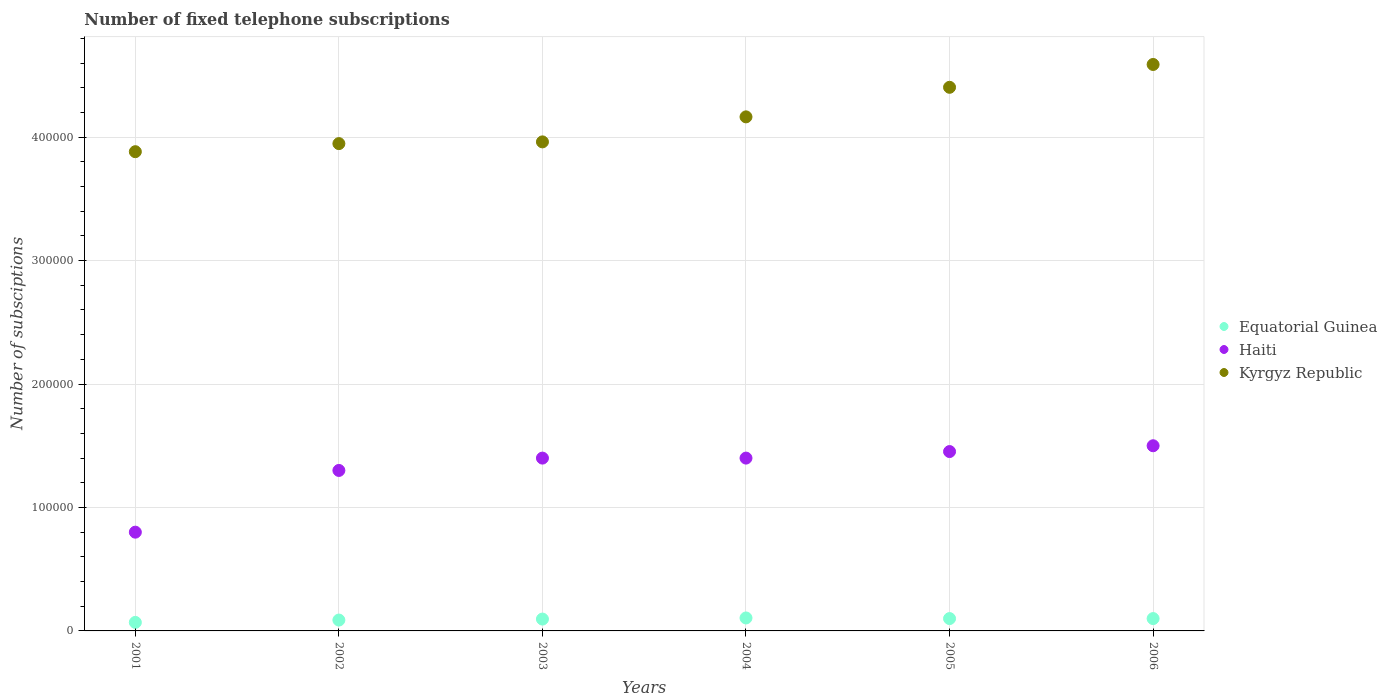What is the number of fixed telephone subscriptions in Kyrgyz Republic in 2003?
Offer a terse response. 3.96e+05. Across all years, what is the maximum number of fixed telephone subscriptions in Haiti?
Give a very brief answer. 1.50e+05. Across all years, what is the minimum number of fixed telephone subscriptions in Equatorial Guinea?
Your answer should be very brief. 6900. In which year was the number of fixed telephone subscriptions in Equatorial Guinea maximum?
Offer a very short reply. 2004. In which year was the number of fixed telephone subscriptions in Equatorial Guinea minimum?
Your answer should be compact. 2001. What is the total number of fixed telephone subscriptions in Haiti in the graph?
Your answer should be very brief. 7.85e+05. What is the difference between the number of fixed telephone subscriptions in Equatorial Guinea in 2006 and the number of fixed telephone subscriptions in Haiti in 2001?
Your response must be concise. -7.00e+04. What is the average number of fixed telephone subscriptions in Haiti per year?
Keep it short and to the point. 1.31e+05. In the year 2002, what is the difference between the number of fixed telephone subscriptions in Equatorial Guinea and number of fixed telephone subscriptions in Haiti?
Keep it short and to the point. -1.21e+05. What is the ratio of the number of fixed telephone subscriptions in Haiti in 2002 to that in 2003?
Give a very brief answer. 0.93. Is the number of fixed telephone subscriptions in Haiti in 2003 less than that in 2005?
Offer a terse response. Yes. Is the difference between the number of fixed telephone subscriptions in Equatorial Guinea in 2004 and 2005 greater than the difference between the number of fixed telephone subscriptions in Haiti in 2004 and 2005?
Provide a succinct answer. Yes. In how many years, is the number of fixed telephone subscriptions in Haiti greater than the average number of fixed telephone subscriptions in Haiti taken over all years?
Keep it short and to the point. 4. Is it the case that in every year, the sum of the number of fixed telephone subscriptions in Equatorial Guinea and number of fixed telephone subscriptions in Kyrgyz Republic  is greater than the number of fixed telephone subscriptions in Haiti?
Your response must be concise. Yes. Does the number of fixed telephone subscriptions in Equatorial Guinea monotonically increase over the years?
Your response must be concise. No. Is the number of fixed telephone subscriptions in Equatorial Guinea strictly greater than the number of fixed telephone subscriptions in Haiti over the years?
Your answer should be compact. No. Is the number of fixed telephone subscriptions in Kyrgyz Republic strictly less than the number of fixed telephone subscriptions in Equatorial Guinea over the years?
Give a very brief answer. No. What is the difference between two consecutive major ticks on the Y-axis?
Your answer should be very brief. 1.00e+05. Are the values on the major ticks of Y-axis written in scientific E-notation?
Your answer should be very brief. No. Does the graph contain any zero values?
Your response must be concise. No. Where does the legend appear in the graph?
Keep it short and to the point. Center right. How many legend labels are there?
Your response must be concise. 3. How are the legend labels stacked?
Provide a short and direct response. Vertical. What is the title of the graph?
Your response must be concise. Number of fixed telephone subscriptions. What is the label or title of the Y-axis?
Offer a very short reply. Number of subsciptions. What is the Number of subsciptions of Equatorial Guinea in 2001?
Keep it short and to the point. 6900. What is the Number of subsciptions of Haiti in 2001?
Offer a terse response. 8.00e+04. What is the Number of subsciptions of Kyrgyz Republic in 2001?
Offer a terse response. 3.88e+05. What is the Number of subsciptions of Equatorial Guinea in 2002?
Your response must be concise. 8800. What is the Number of subsciptions of Haiti in 2002?
Your answer should be very brief. 1.30e+05. What is the Number of subsciptions of Kyrgyz Republic in 2002?
Your answer should be compact. 3.95e+05. What is the Number of subsciptions in Equatorial Guinea in 2003?
Make the answer very short. 9600. What is the Number of subsciptions in Haiti in 2003?
Keep it short and to the point. 1.40e+05. What is the Number of subsciptions of Kyrgyz Republic in 2003?
Your answer should be compact. 3.96e+05. What is the Number of subsciptions of Equatorial Guinea in 2004?
Provide a succinct answer. 1.05e+04. What is the Number of subsciptions of Haiti in 2004?
Offer a very short reply. 1.40e+05. What is the Number of subsciptions of Kyrgyz Republic in 2004?
Provide a succinct answer. 4.16e+05. What is the Number of subsciptions in Haiti in 2005?
Provide a short and direct response. 1.45e+05. What is the Number of subsciptions of Kyrgyz Republic in 2005?
Offer a very short reply. 4.40e+05. What is the Number of subsciptions in Haiti in 2006?
Your response must be concise. 1.50e+05. What is the Number of subsciptions of Kyrgyz Republic in 2006?
Ensure brevity in your answer.  4.59e+05. Across all years, what is the maximum Number of subsciptions of Equatorial Guinea?
Your answer should be very brief. 1.05e+04. Across all years, what is the maximum Number of subsciptions of Kyrgyz Republic?
Ensure brevity in your answer.  4.59e+05. Across all years, what is the minimum Number of subsciptions in Equatorial Guinea?
Give a very brief answer. 6900. Across all years, what is the minimum Number of subsciptions of Haiti?
Provide a short and direct response. 8.00e+04. Across all years, what is the minimum Number of subsciptions in Kyrgyz Republic?
Your response must be concise. 3.88e+05. What is the total Number of subsciptions of Equatorial Guinea in the graph?
Your answer should be compact. 5.58e+04. What is the total Number of subsciptions of Haiti in the graph?
Offer a terse response. 7.85e+05. What is the total Number of subsciptions of Kyrgyz Republic in the graph?
Ensure brevity in your answer.  2.49e+06. What is the difference between the Number of subsciptions of Equatorial Guinea in 2001 and that in 2002?
Ensure brevity in your answer.  -1900. What is the difference between the Number of subsciptions of Haiti in 2001 and that in 2002?
Your answer should be compact. -5.00e+04. What is the difference between the Number of subsciptions of Kyrgyz Republic in 2001 and that in 2002?
Keep it short and to the point. -6548. What is the difference between the Number of subsciptions in Equatorial Guinea in 2001 and that in 2003?
Provide a short and direct response. -2700. What is the difference between the Number of subsciptions of Kyrgyz Republic in 2001 and that in 2003?
Provide a succinct answer. -7946. What is the difference between the Number of subsciptions of Equatorial Guinea in 2001 and that in 2004?
Ensure brevity in your answer.  -3600. What is the difference between the Number of subsciptions of Haiti in 2001 and that in 2004?
Offer a terse response. -6.00e+04. What is the difference between the Number of subsciptions in Kyrgyz Republic in 2001 and that in 2004?
Your answer should be compact. -2.82e+04. What is the difference between the Number of subsciptions in Equatorial Guinea in 2001 and that in 2005?
Give a very brief answer. -3100. What is the difference between the Number of subsciptions of Haiti in 2001 and that in 2005?
Keep it short and to the point. -6.53e+04. What is the difference between the Number of subsciptions of Kyrgyz Republic in 2001 and that in 2005?
Keep it short and to the point. -5.22e+04. What is the difference between the Number of subsciptions in Equatorial Guinea in 2001 and that in 2006?
Your response must be concise. -3100. What is the difference between the Number of subsciptions in Haiti in 2001 and that in 2006?
Give a very brief answer. -7.00e+04. What is the difference between the Number of subsciptions in Kyrgyz Republic in 2001 and that in 2006?
Offer a very short reply. -7.07e+04. What is the difference between the Number of subsciptions in Equatorial Guinea in 2002 and that in 2003?
Your answer should be compact. -800. What is the difference between the Number of subsciptions in Haiti in 2002 and that in 2003?
Provide a succinct answer. -10000. What is the difference between the Number of subsciptions in Kyrgyz Republic in 2002 and that in 2003?
Offer a terse response. -1398. What is the difference between the Number of subsciptions in Equatorial Guinea in 2002 and that in 2004?
Provide a short and direct response. -1700. What is the difference between the Number of subsciptions in Kyrgyz Republic in 2002 and that in 2004?
Provide a succinct answer. -2.17e+04. What is the difference between the Number of subsciptions in Equatorial Guinea in 2002 and that in 2005?
Ensure brevity in your answer.  -1200. What is the difference between the Number of subsciptions in Haiti in 2002 and that in 2005?
Give a very brief answer. -1.53e+04. What is the difference between the Number of subsciptions of Kyrgyz Republic in 2002 and that in 2005?
Keep it short and to the point. -4.56e+04. What is the difference between the Number of subsciptions of Equatorial Guinea in 2002 and that in 2006?
Provide a short and direct response. -1200. What is the difference between the Number of subsciptions in Haiti in 2002 and that in 2006?
Provide a succinct answer. -2.00e+04. What is the difference between the Number of subsciptions of Kyrgyz Republic in 2002 and that in 2006?
Your answer should be compact. -6.41e+04. What is the difference between the Number of subsciptions of Equatorial Guinea in 2003 and that in 2004?
Offer a terse response. -900. What is the difference between the Number of subsciptions in Haiti in 2003 and that in 2004?
Your answer should be compact. 0. What is the difference between the Number of subsciptions of Kyrgyz Republic in 2003 and that in 2004?
Offer a terse response. -2.03e+04. What is the difference between the Number of subsciptions of Equatorial Guinea in 2003 and that in 2005?
Offer a very short reply. -400. What is the difference between the Number of subsciptions of Haiti in 2003 and that in 2005?
Offer a very short reply. -5300. What is the difference between the Number of subsciptions of Kyrgyz Republic in 2003 and that in 2005?
Keep it short and to the point. -4.42e+04. What is the difference between the Number of subsciptions of Equatorial Guinea in 2003 and that in 2006?
Offer a terse response. -400. What is the difference between the Number of subsciptions in Haiti in 2003 and that in 2006?
Your response must be concise. -10000. What is the difference between the Number of subsciptions of Kyrgyz Republic in 2003 and that in 2006?
Make the answer very short. -6.27e+04. What is the difference between the Number of subsciptions of Equatorial Guinea in 2004 and that in 2005?
Provide a succinct answer. 500. What is the difference between the Number of subsciptions of Haiti in 2004 and that in 2005?
Your answer should be very brief. -5300. What is the difference between the Number of subsciptions in Kyrgyz Republic in 2004 and that in 2005?
Your answer should be compact. -2.40e+04. What is the difference between the Number of subsciptions of Equatorial Guinea in 2004 and that in 2006?
Provide a succinct answer. 500. What is the difference between the Number of subsciptions in Haiti in 2004 and that in 2006?
Provide a succinct answer. -10000. What is the difference between the Number of subsciptions of Kyrgyz Republic in 2004 and that in 2006?
Ensure brevity in your answer.  -4.24e+04. What is the difference between the Number of subsciptions in Haiti in 2005 and that in 2006?
Ensure brevity in your answer.  -4700. What is the difference between the Number of subsciptions in Kyrgyz Republic in 2005 and that in 2006?
Offer a terse response. -1.85e+04. What is the difference between the Number of subsciptions in Equatorial Guinea in 2001 and the Number of subsciptions in Haiti in 2002?
Provide a short and direct response. -1.23e+05. What is the difference between the Number of subsciptions in Equatorial Guinea in 2001 and the Number of subsciptions in Kyrgyz Republic in 2002?
Your response must be concise. -3.88e+05. What is the difference between the Number of subsciptions of Haiti in 2001 and the Number of subsciptions of Kyrgyz Republic in 2002?
Your answer should be very brief. -3.15e+05. What is the difference between the Number of subsciptions in Equatorial Guinea in 2001 and the Number of subsciptions in Haiti in 2003?
Your answer should be very brief. -1.33e+05. What is the difference between the Number of subsciptions in Equatorial Guinea in 2001 and the Number of subsciptions in Kyrgyz Republic in 2003?
Make the answer very short. -3.89e+05. What is the difference between the Number of subsciptions in Haiti in 2001 and the Number of subsciptions in Kyrgyz Republic in 2003?
Provide a short and direct response. -3.16e+05. What is the difference between the Number of subsciptions of Equatorial Guinea in 2001 and the Number of subsciptions of Haiti in 2004?
Ensure brevity in your answer.  -1.33e+05. What is the difference between the Number of subsciptions of Equatorial Guinea in 2001 and the Number of subsciptions of Kyrgyz Republic in 2004?
Make the answer very short. -4.10e+05. What is the difference between the Number of subsciptions of Haiti in 2001 and the Number of subsciptions of Kyrgyz Republic in 2004?
Provide a succinct answer. -3.36e+05. What is the difference between the Number of subsciptions of Equatorial Guinea in 2001 and the Number of subsciptions of Haiti in 2005?
Offer a terse response. -1.38e+05. What is the difference between the Number of subsciptions of Equatorial Guinea in 2001 and the Number of subsciptions of Kyrgyz Republic in 2005?
Offer a terse response. -4.33e+05. What is the difference between the Number of subsciptions in Haiti in 2001 and the Number of subsciptions in Kyrgyz Republic in 2005?
Your answer should be compact. -3.60e+05. What is the difference between the Number of subsciptions of Equatorial Guinea in 2001 and the Number of subsciptions of Haiti in 2006?
Keep it short and to the point. -1.43e+05. What is the difference between the Number of subsciptions of Equatorial Guinea in 2001 and the Number of subsciptions of Kyrgyz Republic in 2006?
Make the answer very short. -4.52e+05. What is the difference between the Number of subsciptions of Haiti in 2001 and the Number of subsciptions of Kyrgyz Republic in 2006?
Your answer should be compact. -3.79e+05. What is the difference between the Number of subsciptions of Equatorial Guinea in 2002 and the Number of subsciptions of Haiti in 2003?
Keep it short and to the point. -1.31e+05. What is the difference between the Number of subsciptions of Equatorial Guinea in 2002 and the Number of subsciptions of Kyrgyz Republic in 2003?
Offer a terse response. -3.87e+05. What is the difference between the Number of subsciptions of Haiti in 2002 and the Number of subsciptions of Kyrgyz Republic in 2003?
Your response must be concise. -2.66e+05. What is the difference between the Number of subsciptions of Equatorial Guinea in 2002 and the Number of subsciptions of Haiti in 2004?
Give a very brief answer. -1.31e+05. What is the difference between the Number of subsciptions of Equatorial Guinea in 2002 and the Number of subsciptions of Kyrgyz Republic in 2004?
Provide a short and direct response. -4.08e+05. What is the difference between the Number of subsciptions of Haiti in 2002 and the Number of subsciptions of Kyrgyz Republic in 2004?
Offer a terse response. -2.86e+05. What is the difference between the Number of subsciptions of Equatorial Guinea in 2002 and the Number of subsciptions of Haiti in 2005?
Provide a succinct answer. -1.36e+05. What is the difference between the Number of subsciptions of Equatorial Guinea in 2002 and the Number of subsciptions of Kyrgyz Republic in 2005?
Keep it short and to the point. -4.32e+05. What is the difference between the Number of subsciptions of Haiti in 2002 and the Number of subsciptions of Kyrgyz Republic in 2005?
Keep it short and to the point. -3.10e+05. What is the difference between the Number of subsciptions of Equatorial Guinea in 2002 and the Number of subsciptions of Haiti in 2006?
Your response must be concise. -1.41e+05. What is the difference between the Number of subsciptions in Equatorial Guinea in 2002 and the Number of subsciptions in Kyrgyz Republic in 2006?
Your answer should be very brief. -4.50e+05. What is the difference between the Number of subsciptions of Haiti in 2002 and the Number of subsciptions of Kyrgyz Republic in 2006?
Your answer should be compact. -3.29e+05. What is the difference between the Number of subsciptions in Equatorial Guinea in 2003 and the Number of subsciptions in Haiti in 2004?
Your response must be concise. -1.30e+05. What is the difference between the Number of subsciptions of Equatorial Guinea in 2003 and the Number of subsciptions of Kyrgyz Republic in 2004?
Offer a very short reply. -4.07e+05. What is the difference between the Number of subsciptions in Haiti in 2003 and the Number of subsciptions in Kyrgyz Republic in 2004?
Your answer should be very brief. -2.76e+05. What is the difference between the Number of subsciptions in Equatorial Guinea in 2003 and the Number of subsciptions in Haiti in 2005?
Your response must be concise. -1.36e+05. What is the difference between the Number of subsciptions in Equatorial Guinea in 2003 and the Number of subsciptions in Kyrgyz Republic in 2005?
Keep it short and to the point. -4.31e+05. What is the difference between the Number of subsciptions in Haiti in 2003 and the Number of subsciptions in Kyrgyz Republic in 2005?
Keep it short and to the point. -3.00e+05. What is the difference between the Number of subsciptions in Equatorial Guinea in 2003 and the Number of subsciptions in Haiti in 2006?
Your answer should be very brief. -1.40e+05. What is the difference between the Number of subsciptions in Equatorial Guinea in 2003 and the Number of subsciptions in Kyrgyz Republic in 2006?
Provide a succinct answer. -4.49e+05. What is the difference between the Number of subsciptions in Haiti in 2003 and the Number of subsciptions in Kyrgyz Republic in 2006?
Offer a very short reply. -3.19e+05. What is the difference between the Number of subsciptions of Equatorial Guinea in 2004 and the Number of subsciptions of Haiti in 2005?
Provide a succinct answer. -1.35e+05. What is the difference between the Number of subsciptions of Equatorial Guinea in 2004 and the Number of subsciptions of Kyrgyz Republic in 2005?
Make the answer very short. -4.30e+05. What is the difference between the Number of subsciptions in Haiti in 2004 and the Number of subsciptions in Kyrgyz Republic in 2005?
Provide a short and direct response. -3.00e+05. What is the difference between the Number of subsciptions in Equatorial Guinea in 2004 and the Number of subsciptions in Haiti in 2006?
Provide a succinct answer. -1.40e+05. What is the difference between the Number of subsciptions of Equatorial Guinea in 2004 and the Number of subsciptions of Kyrgyz Republic in 2006?
Make the answer very short. -4.48e+05. What is the difference between the Number of subsciptions of Haiti in 2004 and the Number of subsciptions of Kyrgyz Republic in 2006?
Ensure brevity in your answer.  -3.19e+05. What is the difference between the Number of subsciptions of Equatorial Guinea in 2005 and the Number of subsciptions of Kyrgyz Republic in 2006?
Offer a very short reply. -4.49e+05. What is the difference between the Number of subsciptions of Haiti in 2005 and the Number of subsciptions of Kyrgyz Republic in 2006?
Your response must be concise. -3.14e+05. What is the average Number of subsciptions of Equatorial Guinea per year?
Keep it short and to the point. 9300. What is the average Number of subsciptions in Haiti per year?
Provide a short and direct response. 1.31e+05. What is the average Number of subsciptions in Kyrgyz Republic per year?
Provide a short and direct response. 4.16e+05. In the year 2001, what is the difference between the Number of subsciptions in Equatorial Guinea and Number of subsciptions in Haiti?
Ensure brevity in your answer.  -7.31e+04. In the year 2001, what is the difference between the Number of subsciptions of Equatorial Guinea and Number of subsciptions of Kyrgyz Republic?
Provide a succinct answer. -3.81e+05. In the year 2001, what is the difference between the Number of subsciptions of Haiti and Number of subsciptions of Kyrgyz Republic?
Provide a short and direct response. -3.08e+05. In the year 2002, what is the difference between the Number of subsciptions of Equatorial Guinea and Number of subsciptions of Haiti?
Give a very brief answer. -1.21e+05. In the year 2002, what is the difference between the Number of subsciptions of Equatorial Guinea and Number of subsciptions of Kyrgyz Republic?
Offer a very short reply. -3.86e+05. In the year 2002, what is the difference between the Number of subsciptions of Haiti and Number of subsciptions of Kyrgyz Republic?
Give a very brief answer. -2.65e+05. In the year 2003, what is the difference between the Number of subsciptions in Equatorial Guinea and Number of subsciptions in Haiti?
Your answer should be compact. -1.30e+05. In the year 2003, what is the difference between the Number of subsciptions in Equatorial Guinea and Number of subsciptions in Kyrgyz Republic?
Offer a very short reply. -3.87e+05. In the year 2003, what is the difference between the Number of subsciptions of Haiti and Number of subsciptions of Kyrgyz Republic?
Offer a very short reply. -2.56e+05. In the year 2004, what is the difference between the Number of subsciptions in Equatorial Guinea and Number of subsciptions in Haiti?
Keep it short and to the point. -1.30e+05. In the year 2004, what is the difference between the Number of subsciptions of Equatorial Guinea and Number of subsciptions of Kyrgyz Republic?
Provide a short and direct response. -4.06e+05. In the year 2004, what is the difference between the Number of subsciptions of Haiti and Number of subsciptions of Kyrgyz Republic?
Your response must be concise. -2.76e+05. In the year 2005, what is the difference between the Number of subsciptions of Equatorial Guinea and Number of subsciptions of Haiti?
Provide a short and direct response. -1.35e+05. In the year 2005, what is the difference between the Number of subsciptions in Equatorial Guinea and Number of subsciptions in Kyrgyz Republic?
Provide a short and direct response. -4.30e+05. In the year 2005, what is the difference between the Number of subsciptions of Haiti and Number of subsciptions of Kyrgyz Republic?
Offer a terse response. -2.95e+05. In the year 2006, what is the difference between the Number of subsciptions of Equatorial Guinea and Number of subsciptions of Haiti?
Offer a very short reply. -1.40e+05. In the year 2006, what is the difference between the Number of subsciptions in Equatorial Guinea and Number of subsciptions in Kyrgyz Republic?
Make the answer very short. -4.49e+05. In the year 2006, what is the difference between the Number of subsciptions of Haiti and Number of subsciptions of Kyrgyz Republic?
Your response must be concise. -3.09e+05. What is the ratio of the Number of subsciptions of Equatorial Guinea in 2001 to that in 2002?
Give a very brief answer. 0.78. What is the ratio of the Number of subsciptions in Haiti in 2001 to that in 2002?
Make the answer very short. 0.62. What is the ratio of the Number of subsciptions in Kyrgyz Republic in 2001 to that in 2002?
Your answer should be compact. 0.98. What is the ratio of the Number of subsciptions in Equatorial Guinea in 2001 to that in 2003?
Keep it short and to the point. 0.72. What is the ratio of the Number of subsciptions in Haiti in 2001 to that in 2003?
Offer a very short reply. 0.57. What is the ratio of the Number of subsciptions of Kyrgyz Republic in 2001 to that in 2003?
Offer a very short reply. 0.98. What is the ratio of the Number of subsciptions of Equatorial Guinea in 2001 to that in 2004?
Your response must be concise. 0.66. What is the ratio of the Number of subsciptions of Haiti in 2001 to that in 2004?
Ensure brevity in your answer.  0.57. What is the ratio of the Number of subsciptions of Kyrgyz Republic in 2001 to that in 2004?
Make the answer very short. 0.93. What is the ratio of the Number of subsciptions of Equatorial Guinea in 2001 to that in 2005?
Offer a very short reply. 0.69. What is the ratio of the Number of subsciptions in Haiti in 2001 to that in 2005?
Provide a short and direct response. 0.55. What is the ratio of the Number of subsciptions of Kyrgyz Republic in 2001 to that in 2005?
Keep it short and to the point. 0.88. What is the ratio of the Number of subsciptions of Equatorial Guinea in 2001 to that in 2006?
Offer a very short reply. 0.69. What is the ratio of the Number of subsciptions in Haiti in 2001 to that in 2006?
Give a very brief answer. 0.53. What is the ratio of the Number of subsciptions in Kyrgyz Republic in 2001 to that in 2006?
Your answer should be compact. 0.85. What is the ratio of the Number of subsciptions of Equatorial Guinea in 2002 to that in 2003?
Offer a very short reply. 0.92. What is the ratio of the Number of subsciptions in Haiti in 2002 to that in 2003?
Your answer should be compact. 0.93. What is the ratio of the Number of subsciptions in Kyrgyz Republic in 2002 to that in 2003?
Provide a short and direct response. 1. What is the ratio of the Number of subsciptions of Equatorial Guinea in 2002 to that in 2004?
Your answer should be very brief. 0.84. What is the ratio of the Number of subsciptions in Haiti in 2002 to that in 2004?
Your response must be concise. 0.93. What is the ratio of the Number of subsciptions in Kyrgyz Republic in 2002 to that in 2004?
Provide a short and direct response. 0.95. What is the ratio of the Number of subsciptions of Equatorial Guinea in 2002 to that in 2005?
Provide a short and direct response. 0.88. What is the ratio of the Number of subsciptions in Haiti in 2002 to that in 2005?
Provide a short and direct response. 0.89. What is the ratio of the Number of subsciptions of Kyrgyz Republic in 2002 to that in 2005?
Make the answer very short. 0.9. What is the ratio of the Number of subsciptions of Haiti in 2002 to that in 2006?
Make the answer very short. 0.87. What is the ratio of the Number of subsciptions in Kyrgyz Republic in 2002 to that in 2006?
Offer a terse response. 0.86. What is the ratio of the Number of subsciptions in Equatorial Guinea in 2003 to that in 2004?
Offer a very short reply. 0.91. What is the ratio of the Number of subsciptions of Kyrgyz Republic in 2003 to that in 2004?
Keep it short and to the point. 0.95. What is the ratio of the Number of subsciptions in Equatorial Guinea in 2003 to that in 2005?
Provide a short and direct response. 0.96. What is the ratio of the Number of subsciptions in Haiti in 2003 to that in 2005?
Ensure brevity in your answer.  0.96. What is the ratio of the Number of subsciptions of Kyrgyz Republic in 2003 to that in 2005?
Keep it short and to the point. 0.9. What is the ratio of the Number of subsciptions in Kyrgyz Republic in 2003 to that in 2006?
Provide a succinct answer. 0.86. What is the ratio of the Number of subsciptions of Haiti in 2004 to that in 2005?
Offer a very short reply. 0.96. What is the ratio of the Number of subsciptions in Kyrgyz Republic in 2004 to that in 2005?
Provide a succinct answer. 0.95. What is the ratio of the Number of subsciptions of Equatorial Guinea in 2004 to that in 2006?
Your response must be concise. 1.05. What is the ratio of the Number of subsciptions of Haiti in 2004 to that in 2006?
Your response must be concise. 0.93. What is the ratio of the Number of subsciptions of Kyrgyz Republic in 2004 to that in 2006?
Your answer should be very brief. 0.91. What is the ratio of the Number of subsciptions of Haiti in 2005 to that in 2006?
Give a very brief answer. 0.97. What is the ratio of the Number of subsciptions in Kyrgyz Republic in 2005 to that in 2006?
Provide a short and direct response. 0.96. What is the difference between the highest and the second highest Number of subsciptions in Haiti?
Your answer should be very brief. 4700. What is the difference between the highest and the second highest Number of subsciptions of Kyrgyz Republic?
Ensure brevity in your answer.  1.85e+04. What is the difference between the highest and the lowest Number of subsciptions of Equatorial Guinea?
Provide a short and direct response. 3600. What is the difference between the highest and the lowest Number of subsciptions in Haiti?
Your response must be concise. 7.00e+04. What is the difference between the highest and the lowest Number of subsciptions of Kyrgyz Republic?
Your answer should be very brief. 7.07e+04. 